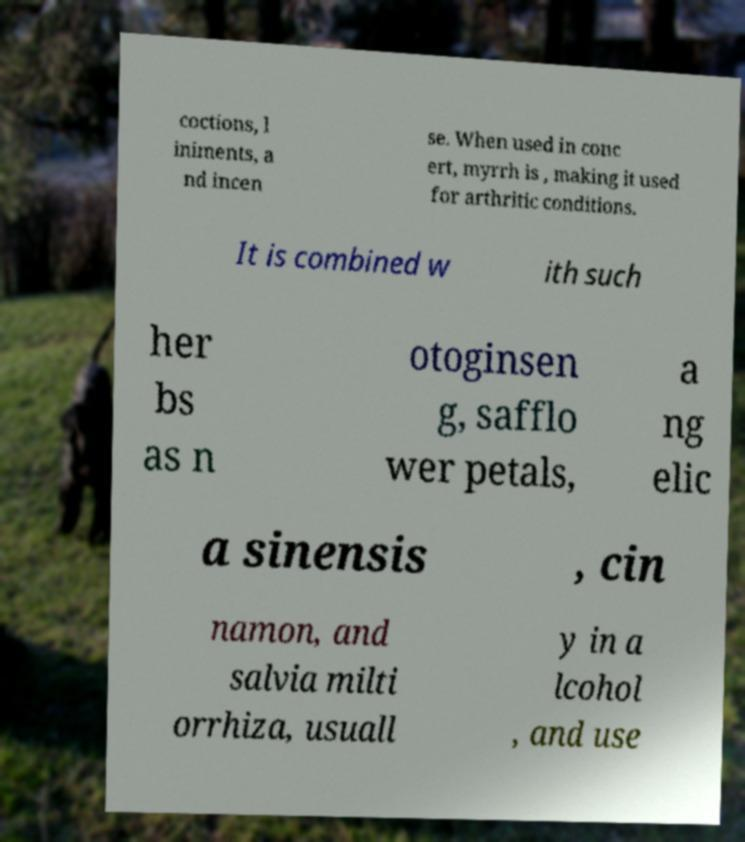Please read and relay the text visible in this image. What does it say? coctions, l iniments, a nd incen se. When used in conc ert, myrrh is , making it used for arthritic conditions. It is combined w ith such her bs as n otoginsen g, safflo wer petals, a ng elic a sinensis , cin namon, and salvia milti orrhiza, usuall y in a lcohol , and use 